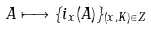<formula> <loc_0><loc_0><loc_500><loc_500>A \longmapsto \{ i _ { x } ( A ) \} _ { ( x , K ) \in Z }</formula> 